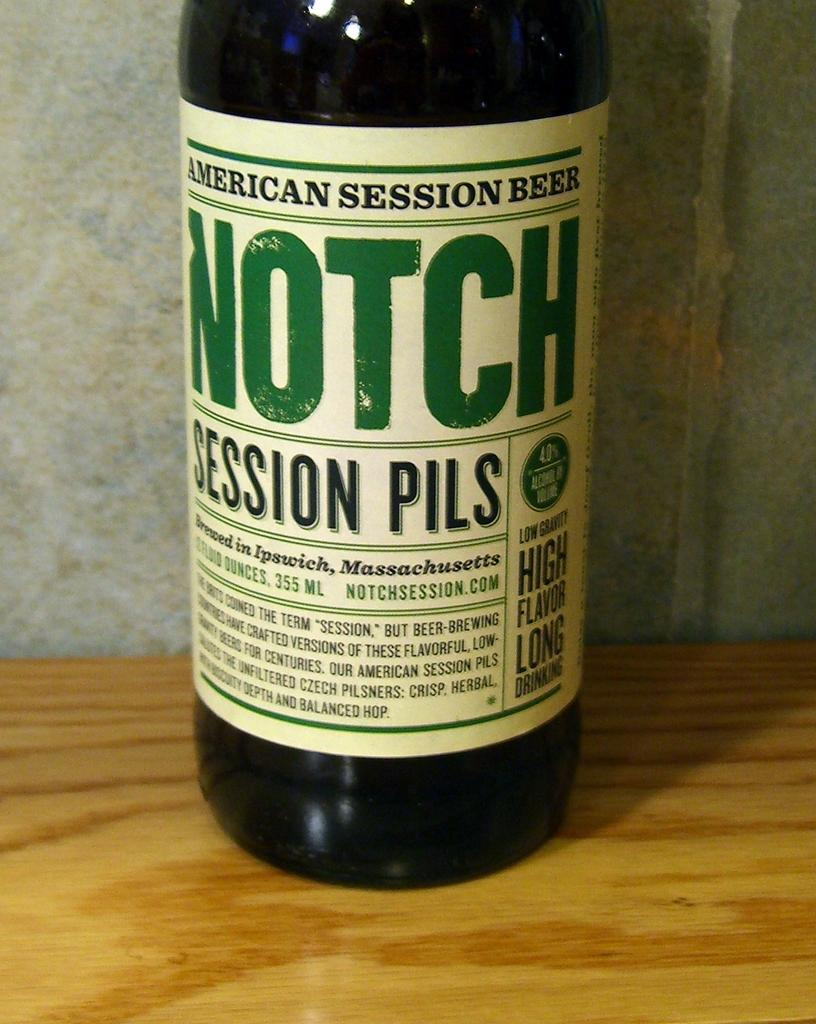<image>
Render a clear and concise summary of the photo. A bottle of Notch American Session Beer is sitting on a table. 